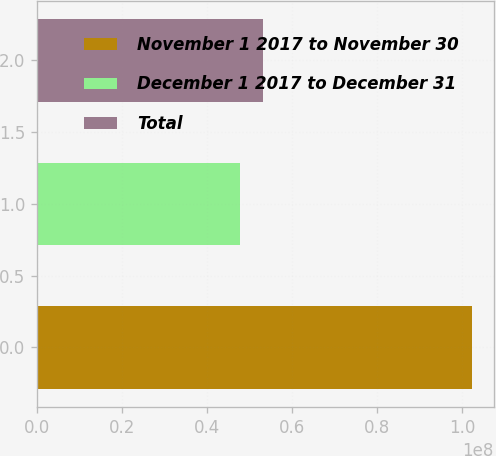Convert chart to OTSL. <chart><loc_0><loc_0><loc_500><loc_500><bar_chart><fcel>November 1 2017 to November 30<fcel>December 1 2017 to December 31<fcel>Total<nl><fcel>1.02299e+08<fcel>4.76596e+07<fcel>5.31236e+07<nl></chart> 